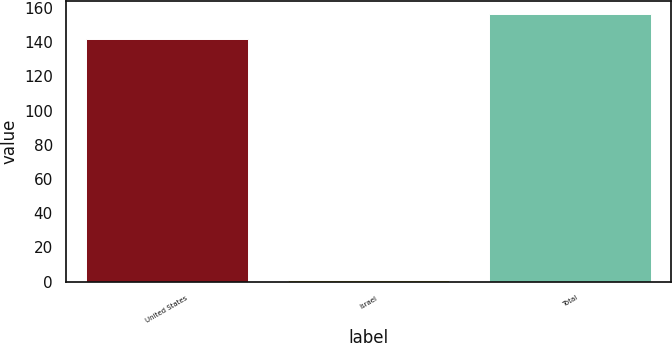<chart> <loc_0><loc_0><loc_500><loc_500><bar_chart><fcel>United States<fcel>Israel<fcel>Total<nl><fcel>142<fcel>1<fcel>156.2<nl></chart> 